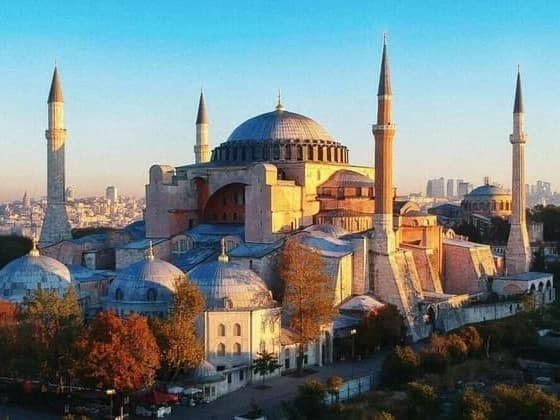Imagine a day in the life of Hagia Sophia from the perspective of a time traveler from the future. As a time traveler from the future, stepping into the realm of Hagia Sophia is an awe-inspiring experience. The dawn breaks over Istanbul, illuminating the iconic structure with a golden glow, its massive dome and minarets standing tall against the modern skyline. Walking through its ancient halls, the time traveler admires the exquisite Byzantine mosaics depicting emperors and saints, marveling at how centuries of history are encapsulated within these walls. The rich scent of aged stone and whispers of past prayers linger in the air, creating an atmosphere both sacred and timeless. As the day progresses, tourists and historians alike navigate its vast interior, their voices a blend of myriad languages, all drawn by the magnetism of the Hagia Sophia. The time traveler observes, reflecting on the wisdom of the builders and the resilience of a structure that has withstood numerous sieges, earthquakes, and reconstructions. By sunset, the Hagia Sophia transforms once more, bathed in a soft twilight, a silent testament to the undying human spirit that created and preserved this marvel. In the serene night, the time traveler contemplates how this ancient gem continues to inspire, embodying the harmonious coexistence of diverse cultures and epochs. Curate a fantasy exhibition on the Hagia Sophia for an intergalactic audience. Welcome to the 'Eternal Echoes of Hagia Sophia,' an intergalactic exhibition that transcends time and space. As you, esteemed visitors from distant galaxies, step into this virtual atrium, you are greeted by a holographic projection of the Hagia Sophia, resplendent in its full glory. The dome above you transforms into a cosmic theater, displaying a visual timeline of the building's illustrious history, from its Byzantine origins, through its Ottoman transformation, to its present grandeur as a symbol of unity.

Interactive exhibits invite you to explore the architectural magnificence of the structure. Experience the ancient techniques used in constructing the immense dome through augmented reality modules. Feel the texture of the golden mosaics, each one a pixel in a grand celestial tapestry, and decode their intricate stories of emperors, angels, and saints.

Step into the 'Soundscapes of Time,' an auditory journey where you can hear the harmonic chants of Byzantine liturgies, the resonant calls to prayer, and even whispers from history's most significant figures associated with the Hagia Sophia.

The 'Illuminated Minarets' section features stellar light shows and visual spectacles that mimic the ethereal glow of the structure at dawn and dusk, allowing you to perceive it in ways unseen by Earthly eyes. Meet virtual guides — architects from the Byzantine, Ottoman, and modern eras — who share their insights and experiences in crafting this architectural wonder.

Finally, for our most advanced cosmic travelers, a special immersive experience: 'The Spirit of Sophia,' where you transcend physical dimensions to understand the philosophical and spiritual essence that has sustained the Hagia Sophia through millennia. This culminating encounter emphasizes the structure’s role as a bridge between cultures, epochs, and worlds, leaving you with an everlasting imprint of human resilience, creativity, and unity.

Join us for an unparalleled cosmic journey, and experience the timeless legacy of the Hagia Sophia, an Earthly marvel resonating across the galaxy. 